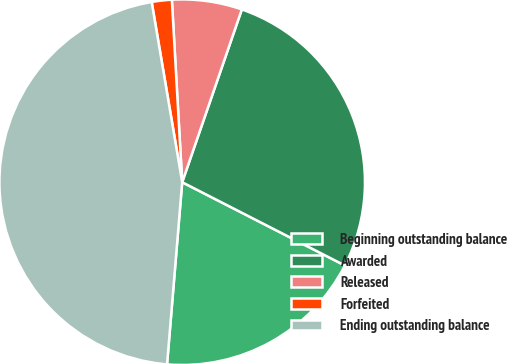Convert chart. <chart><loc_0><loc_0><loc_500><loc_500><pie_chart><fcel>Beginning outstanding balance<fcel>Awarded<fcel>Released<fcel>Forfeited<fcel>Ending outstanding balance<nl><fcel>18.79%<fcel>27.24%<fcel>6.19%<fcel>1.77%<fcel>46.01%<nl></chart> 